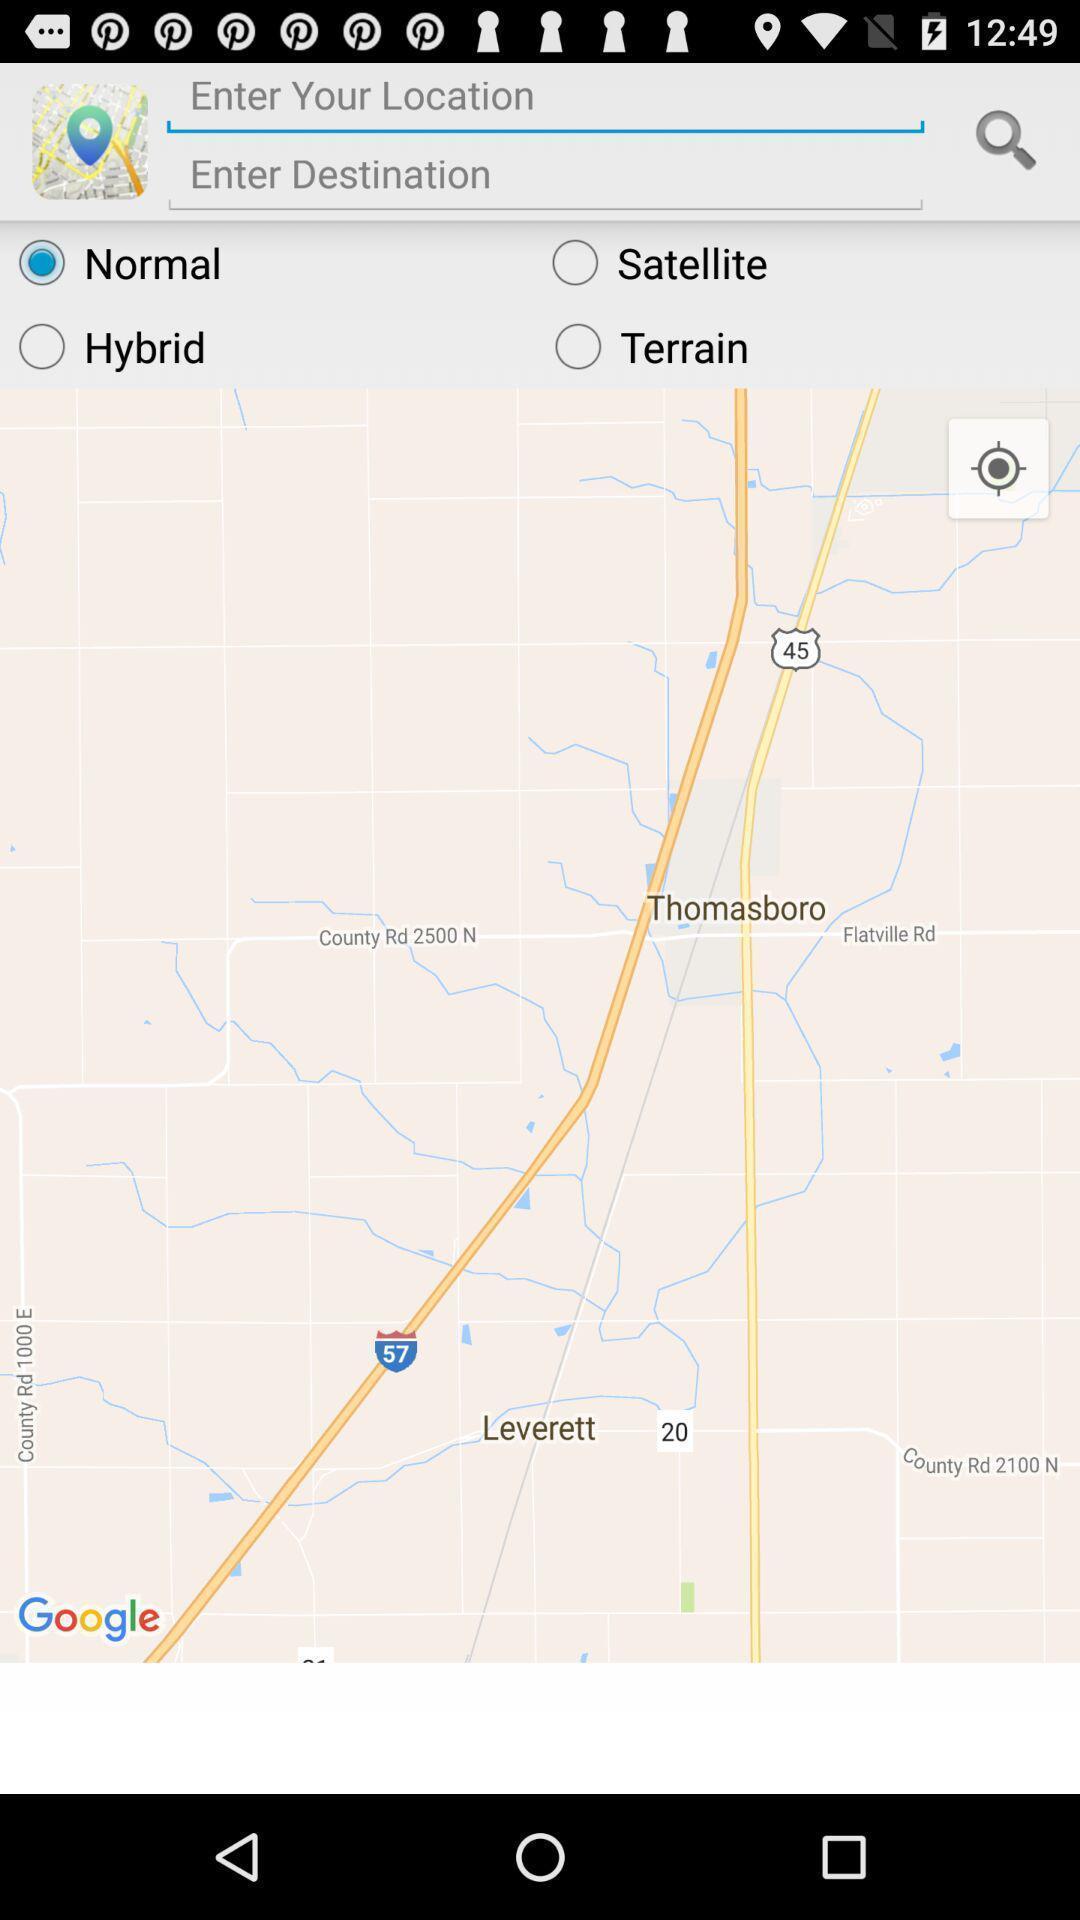Describe this image in words. Screen displaying search bar to find location in route app. 